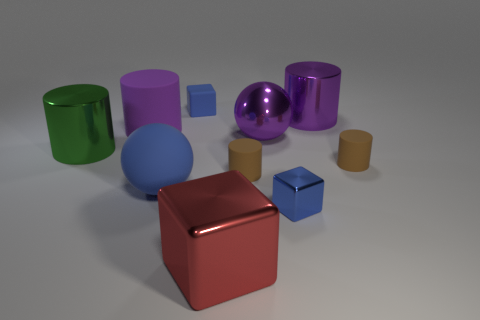How big is the purple cylinder to the right of the blue object that is behind the large purple matte object?
Provide a succinct answer. Large. Is the color of the tiny metallic block the same as the large rubber object that is behind the green cylinder?
Provide a succinct answer. No. What material is the blue ball that is the same size as the green shiny cylinder?
Offer a terse response. Rubber. Is the number of large purple cylinders that are in front of the big matte cylinder less than the number of small blue rubber things that are to the right of the large red cube?
Give a very brief answer. No. The small brown matte thing that is behind the small cylinder that is on the left side of the small shiny thing is what shape?
Offer a very short reply. Cylinder. Is there a purple rubber object?
Your response must be concise. Yes. What color is the tiny matte object that is on the right side of the purple sphere?
Give a very brief answer. Brown. There is a tiny object that is the same color as the tiny metal block; what material is it?
Your answer should be very brief. Rubber. There is a big shiny ball; are there any brown rubber objects on the right side of it?
Ensure brevity in your answer.  Yes. Is the number of large cylinders greater than the number of large yellow metallic things?
Provide a short and direct response. Yes. 